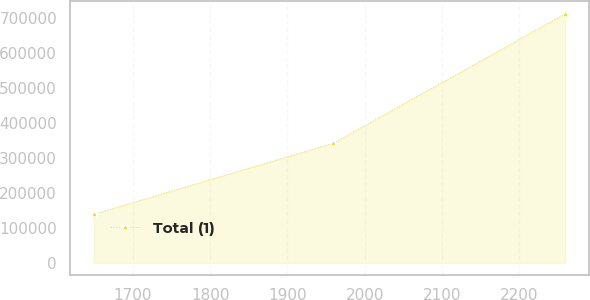Convert chart. <chart><loc_0><loc_0><loc_500><loc_500><line_chart><ecel><fcel>Total (1)<nl><fcel>1649.31<fcel>139254<nl><fcel>1959.41<fcel>341991<nl><fcel>2259.4<fcel>711777<nl></chart> 